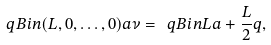<formula> <loc_0><loc_0><loc_500><loc_500>\ q B i n { ( L , 0 , \dots , 0 ) } { a } { \nu } = \ q B i n { L } { a + \frac { L } { 2 } } { q } ,</formula> 